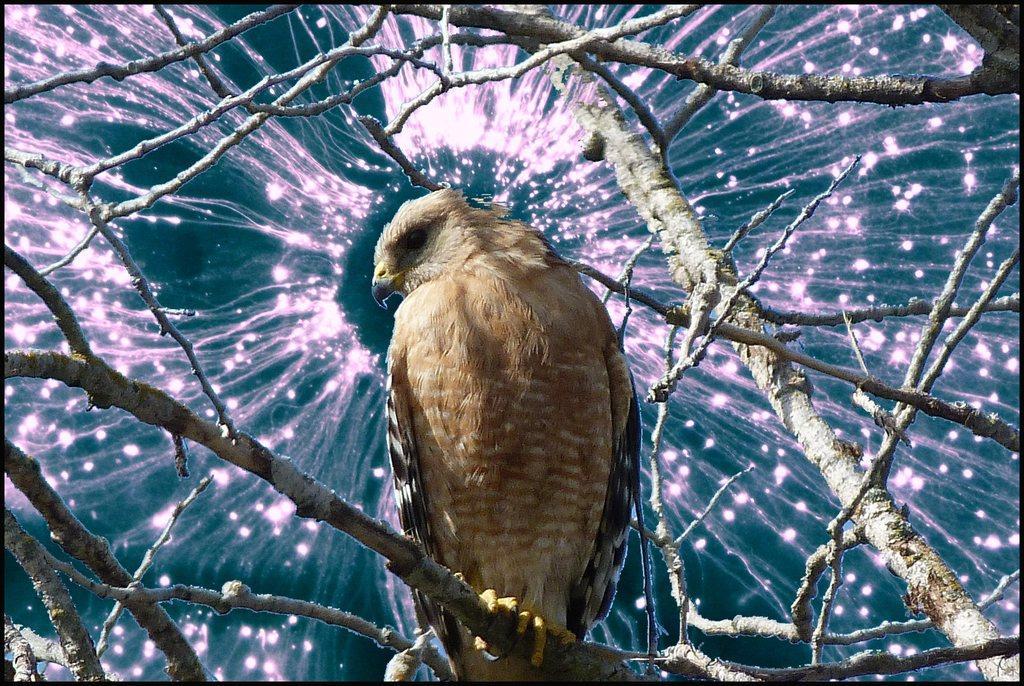Please provide a concise description of this image. This is an edited image where there is a bird standing on the branch of the tree. 